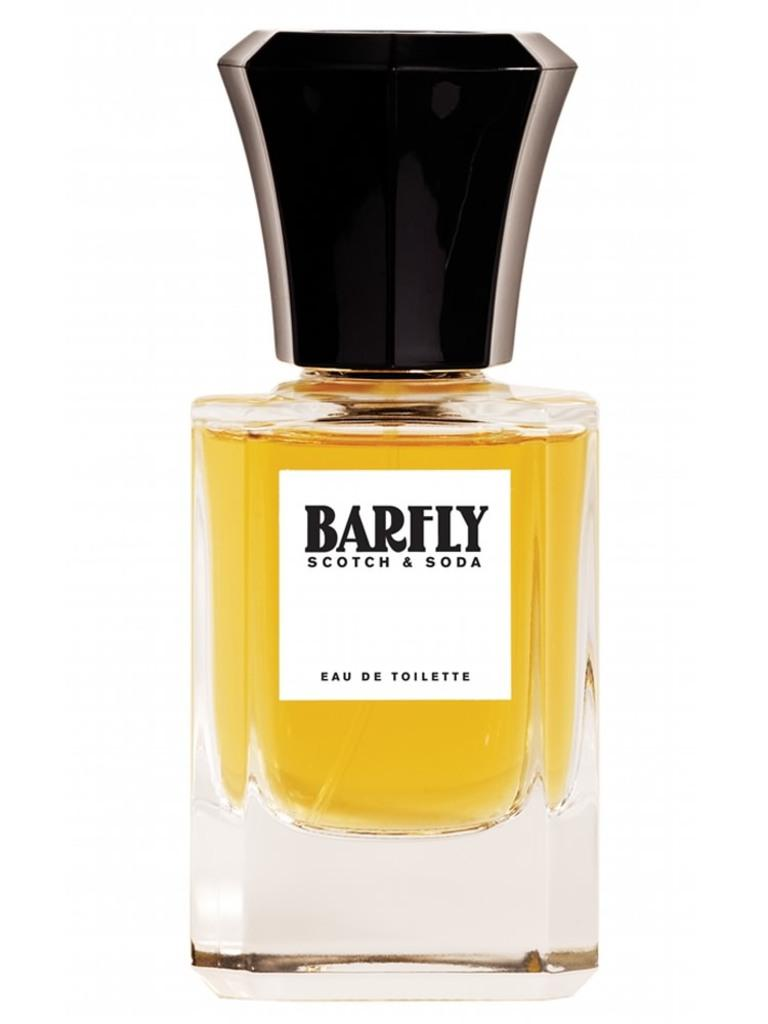<image>
Summarize the visual content of the image. A bottle of yellow Barfly perfume against a white backdrop. 